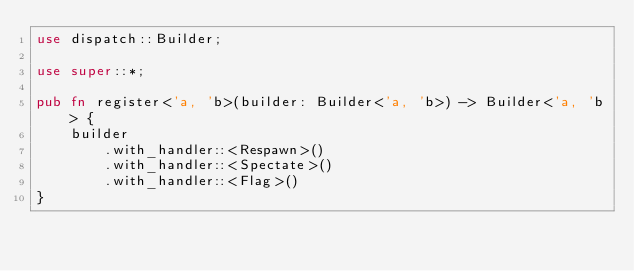Convert code to text. <code><loc_0><loc_0><loc_500><loc_500><_Rust_>use dispatch::Builder;

use super::*;

pub fn register<'a, 'b>(builder: Builder<'a, 'b>) -> Builder<'a, 'b> {
	builder
		.with_handler::<Respawn>()
		.with_handler::<Spectate>()
		.with_handler::<Flag>()
}
</code> 